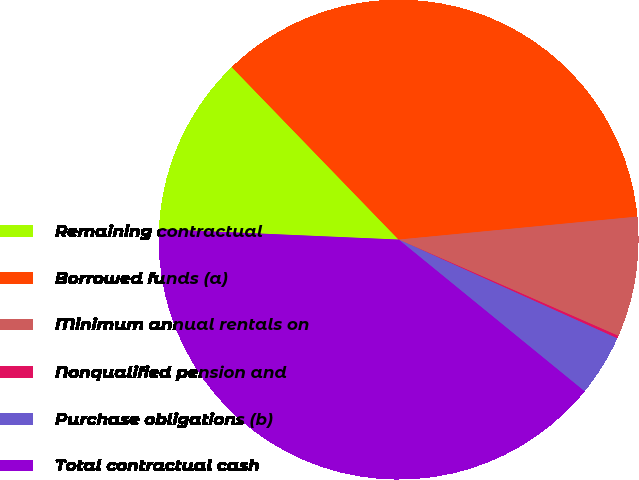Convert chart to OTSL. <chart><loc_0><loc_0><loc_500><loc_500><pie_chart><fcel>Remaining contractual<fcel>Borrowed funds (a)<fcel>Minimum annual rentals on<fcel>Nonqualified pension and<fcel>Purchase obligations (b)<fcel>Total contractual cash<nl><fcel>12.07%<fcel>35.71%<fcel>8.1%<fcel>0.18%<fcel>4.14%<fcel>39.8%<nl></chart> 